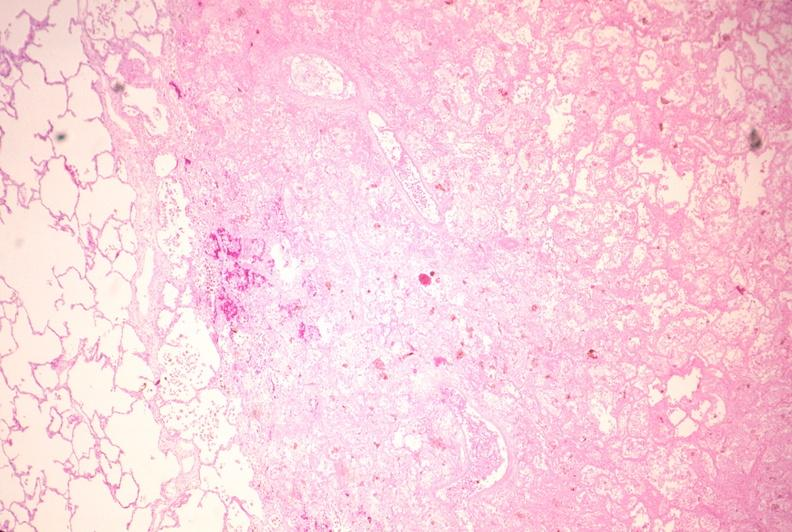where is this?
Answer the question using a single word or phrase. Lung 